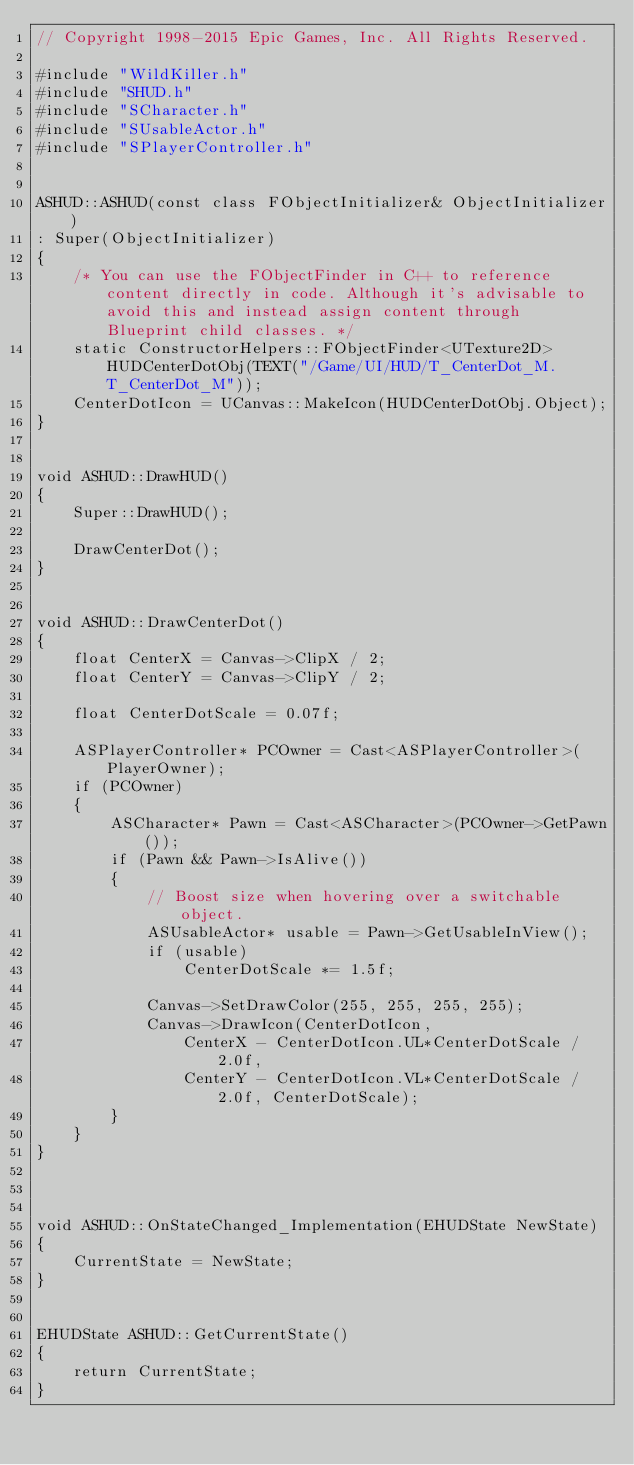Convert code to text. <code><loc_0><loc_0><loc_500><loc_500><_C++_>// Copyright 1998-2015 Epic Games, Inc. All Rights Reserved.

#include "WildKiller.h"
#include "SHUD.h"
#include "SCharacter.h"
#include "SUsableActor.h"
#include "SPlayerController.h"


ASHUD::ASHUD(const class FObjectInitializer& ObjectInitializer)
: Super(ObjectInitializer)
{
	/* You can use the FObjectFinder in C++ to reference content directly in code. Although it's advisable to avoid this and instead assign content through Blueprint child classes. */
	static ConstructorHelpers::FObjectFinder<UTexture2D> HUDCenterDotObj(TEXT("/Game/UI/HUD/T_CenterDot_M.T_CenterDot_M"));
	CenterDotIcon = UCanvas::MakeIcon(HUDCenterDotObj.Object);
}


void ASHUD::DrawHUD()
{
	Super::DrawHUD();

	DrawCenterDot();
}


void ASHUD::DrawCenterDot()
{
	float CenterX = Canvas->ClipX / 2;
	float CenterY = Canvas->ClipY / 2;

	float CenterDotScale = 0.07f;

	ASPlayerController* PCOwner = Cast<ASPlayerController>(PlayerOwner);
	if (PCOwner)
	{
		ASCharacter* Pawn = Cast<ASCharacter>(PCOwner->GetPawn());
		if (Pawn && Pawn->IsAlive())
		{
			// Boost size when hovering over a switchable object.
			ASUsableActor* usable = Pawn->GetUsableInView();
			if (usable)
				CenterDotScale *= 1.5f;

			Canvas->SetDrawColor(255, 255, 255, 255);
			Canvas->DrawIcon(CenterDotIcon,
				CenterX - CenterDotIcon.UL*CenterDotScale / 2.0f,
				CenterY - CenterDotIcon.VL*CenterDotScale / 2.0f, CenterDotScale);
		}
	}
}



void ASHUD::OnStateChanged_Implementation(EHUDState NewState)
{
	CurrentState = NewState;
}


EHUDState ASHUD::GetCurrentState()
{
	return CurrentState;
}
</code> 